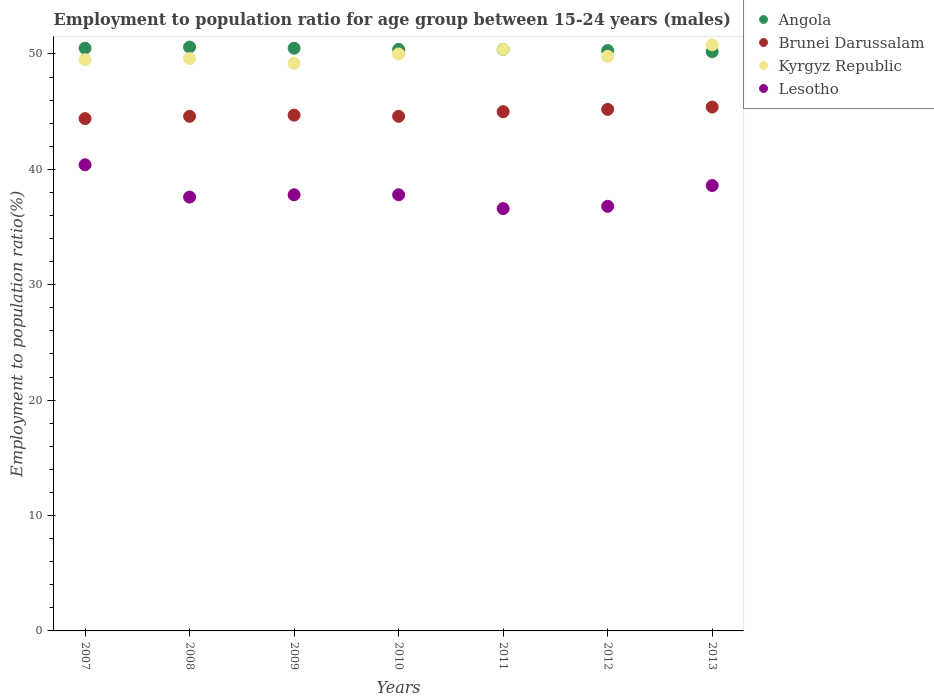Is the number of dotlines equal to the number of legend labels?
Provide a short and direct response. Yes. What is the employment to population ratio in Brunei Darussalam in 2009?
Your answer should be compact. 44.7. Across all years, what is the maximum employment to population ratio in Lesotho?
Your response must be concise. 40.4. Across all years, what is the minimum employment to population ratio in Angola?
Provide a short and direct response. 50.2. What is the total employment to population ratio in Angola in the graph?
Offer a very short reply. 352.9. What is the difference between the employment to population ratio in Lesotho in 2007 and that in 2010?
Your response must be concise. 2.6. What is the difference between the employment to population ratio in Angola in 2007 and the employment to population ratio in Brunei Darussalam in 2012?
Make the answer very short. 5.3. What is the average employment to population ratio in Brunei Darussalam per year?
Give a very brief answer. 44.84. In the year 2010, what is the difference between the employment to population ratio in Lesotho and employment to population ratio in Angola?
Give a very brief answer. -12.6. What is the ratio of the employment to population ratio in Kyrgyz Republic in 2008 to that in 2012?
Give a very brief answer. 1. Is the employment to population ratio in Angola in 2007 less than that in 2012?
Make the answer very short. No. What is the difference between the highest and the second highest employment to population ratio in Lesotho?
Keep it short and to the point. 1.8. What is the difference between the highest and the lowest employment to population ratio in Angola?
Provide a succinct answer. 0.4. In how many years, is the employment to population ratio in Angola greater than the average employment to population ratio in Angola taken over all years?
Your answer should be compact. 3. Is it the case that in every year, the sum of the employment to population ratio in Lesotho and employment to population ratio in Angola  is greater than the sum of employment to population ratio in Kyrgyz Republic and employment to population ratio in Brunei Darussalam?
Provide a short and direct response. No. Is it the case that in every year, the sum of the employment to population ratio in Kyrgyz Republic and employment to population ratio in Brunei Darussalam  is greater than the employment to population ratio in Lesotho?
Keep it short and to the point. Yes. Does the employment to population ratio in Angola monotonically increase over the years?
Your answer should be compact. No. Is the employment to population ratio in Brunei Darussalam strictly less than the employment to population ratio in Angola over the years?
Make the answer very short. Yes. How many dotlines are there?
Your response must be concise. 4. How many years are there in the graph?
Keep it short and to the point. 7. What is the difference between two consecutive major ticks on the Y-axis?
Your answer should be very brief. 10. Are the values on the major ticks of Y-axis written in scientific E-notation?
Your response must be concise. No. Where does the legend appear in the graph?
Your answer should be compact. Top right. What is the title of the graph?
Provide a short and direct response. Employment to population ratio for age group between 15-24 years (males). Does "Gabon" appear as one of the legend labels in the graph?
Offer a very short reply. No. What is the label or title of the X-axis?
Your answer should be very brief. Years. What is the label or title of the Y-axis?
Provide a short and direct response. Employment to population ratio(%). What is the Employment to population ratio(%) of Angola in 2007?
Offer a very short reply. 50.5. What is the Employment to population ratio(%) of Brunei Darussalam in 2007?
Offer a very short reply. 44.4. What is the Employment to population ratio(%) in Kyrgyz Republic in 2007?
Your response must be concise. 49.5. What is the Employment to population ratio(%) of Lesotho in 2007?
Offer a very short reply. 40.4. What is the Employment to population ratio(%) in Angola in 2008?
Your response must be concise. 50.6. What is the Employment to population ratio(%) in Brunei Darussalam in 2008?
Offer a terse response. 44.6. What is the Employment to population ratio(%) in Kyrgyz Republic in 2008?
Provide a succinct answer. 49.6. What is the Employment to population ratio(%) in Lesotho in 2008?
Your response must be concise. 37.6. What is the Employment to population ratio(%) of Angola in 2009?
Your answer should be very brief. 50.5. What is the Employment to population ratio(%) of Brunei Darussalam in 2009?
Ensure brevity in your answer.  44.7. What is the Employment to population ratio(%) of Kyrgyz Republic in 2009?
Your answer should be very brief. 49.2. What is the Employment to population ratio(%) in Lesotho in 2009?
Ensure brevity in your answer.  37.8. What is the Employment to population ratio(%) of Angola in 2010?
Offer a very short reply. 50.4. What is the Employment to population ratio(%) of Brunei Darussalam in 2010?
Keep it short and to the point. 44.6. What is the Employment to population ratio(%) in Lesotho in 2010?
Your answer should be very brief. 37.8. What is the Employment to population ratio(%) of Angola in 2011?
Provide a succinct answer. 50.4. What is the Employment to population ratio(%) in Kyrgyz Republic in 2011?
Your response must be concise. 50.4. What is the Employment to population ratio(%) in Lesotho in 2011?
Offer a terse response. 36.6. What is the Employment to population ratio(%) of Angola in 2012?
Provide a short and direct response. 50.3. What is the Employment to population ratio(%) in Brunei Darussalam in 2012?
Give a very brief answer. 45.2. What is the Employment to population ratio(%) of Kyrgyz Republic in 2012?
Offer a very short reply. 49.8. What is the Employment to population ratio(%) of Lesotho in 2012?
Offer a very short reply. 36.8. What is the Employment to population ratio(%) in Angola in 2013?
Make the answer very short. 50.2. What is the Employment to population ratio(%) of Brunei Darussalam in 2013?
Your answer should be compact. 45.4. What is the Employment to population ratio(%) in Kyrgyz Republic in 2013?
Provide a short and direct response. 50.8. What is the Employment to population ratio(%) in Lesotho in 2013?
Make the answer very short. 38.6. Across all years, what is the maximum Employment to population ratio(%) of Angola?
Provide a short and direct response. 50.6. Across all years, what is the maximum Employment to population ratio(%) of Brunei Darussalam?
Give a very brief answer. 45.4. Across all years, what is the maximum Employment to population ratio(%) in Kyrgyz Republic?
Ensure brevity in your answer.  50.8. Across all years, what is the maximum Employment to population ratio(%) of Lesotho?
Make the answer very short. 40.4. Across all years, what is the minimum Employment to population ratio(%) of Angola?
Ensure brevity in your answer.  50.2. Across all years, what is the minimum Employment to population ratio(%) of Brunei Darussalam?
Provide a short and direct response. 44.4. Across all years, what is the minimum Employment to population ratio(%) in Kyrgyz Republic?
Offer a very short reply. 49.2. Across all years, what is the minimum Employment to population ratio(%) of Lesotho?
Provide a short and direct response. 36.6. What is the total Employment to population ratio(%) of Angola in the graph?
Make the answer very short. 352.9. What is the total Employment to population ratio(%) in Brunei Darussalam in the graph?
Your answer should be very brief. 313.9. What is the total Employment to population ratio(%) in Kyrgyz Republic in the graph?
Keep it short and to the point. 349.3. What is the total Employment to population ratio(%) of Lesotho in the graph?
Offer a very short reply. 265.6. What is the difference between the Employment to population ratio(%) in Brunei Darussalam in 2007 and that in 2008?
Offer a very short reply. -0.2. What is the difference between the Employment to population ratio(%) of Kyrgyz Republic in 2007 and that in 2008?
Offer a very short reply. -0.1. What is the difference between the Employment to population ratio(%) of Brunei Darussalam in 2007 and that in 2009?
Offer a very short reply. -0.3. What is the difference between the Employment to population ratio(%) in Kyrgyz Republic in 2007 and that in 2009?
Make the answer very short. 0.3. What is the difference between the Employment to population ratio(%) in Lesotho in 2007 and that in 2009?
Provide a short and direct response. 2.6. What is the difference between the Employment to population ratio(%) in Angola in 2007 and that in 2010?
Keep it short and to the point. 0.1. What is the difference between the Employment to population ratio(%) in Lesotho in 2007 and that in 2010?
Make the answer very short. 2.6. What is the difference between the Employment to population ratio(%) of Angola in 2007 and that in 2011?
Your response must be concise. 0.1. What is the difference between the Employment to population ratio(%) of Brunei Darussalam in 2007 and that in 2011?
Your answer should be very brief. -0.6. What is the difference between the Employment to population ratio(%) in Kyrgyz Republic in 2007 and that in 2011?
Your response must be concise. -0.9. What is the difference between the Employment to population ratio(%) of Lesotho in 2007 and that in 2011?
Ensure brevity in your answer.  3.8. What is the difference between the Employment to population ratio(%) in Brunei Darussalam in 2007 and that in 2012?
Provide a short and direct response. -0.8. What is the difference between the Employment to population ratio(%) in Lesotho in 2007 and that in 2012?
Provide a succinct answer. 3.6. What is the difference between the Employment to population ratio(%) in Brunei Darussalam in 2007 and that in 2013?
Offer a very short reply. -1. What is the difference between the Employment to population ratio(%) of Kyrgyz Republic in 2007 and that in 2013?
Ensure brevity in your answer.  -1.3. What is the difference between the Employment to population ratio(%) of Angola in 2008 and that in 2009?
Your answer should be very brief. 0.1. What is the difference between the Employment to population ratio(%) in Brunei Darussalam in 2008 and that in 2009?
Give a very brief answer. -0.1. What is the difference between the Employment to population ratio(%) in Lesotho in 2008 and that in 2009?
Make the answer very short. -0.2. What is the difference between the Employment to population ratio(%) of Brunei Darussalam in 2008 and that in 2010?
Make the answer very short. 0. What is the difference between the Employment to population ratio(%) of Angola in 2008 and that in 2011?
Provide a short and direct response. 0.2. What is the difference between the Employment to population ratio(%) in Brunei Darussalam in 2008 and that in 2011?
Make the answer very short. -0.4. What is the difference between the Employment to population ratio(%) in Lesotho in 2008 and that in 2011?
Your answer should be very brief. 1. What is the difference between the Employment to population ratio(%) in Angola in 2008 and that in 2012?
Provide a succinct answer. 0.3. What is the difference between the Employment to population ratio(%) of Brunei Darussalam in 2008 and that in 2012?
Keep it short and to the point. -0.6. What is the difference between the Employment to population ratio(%) of Kyrgyz Republic in 2008 and that in 2012?
Provide a succinct answer. -0.2. What is the difference between the Employment to population ratio(%) in Lesotho in 2008 and that in 2012?
Your answer should be compact. 0.8. What is the difference between the Employment to population ratio(%) of Angola in 2008 and that in 2013?
Provide a succinct answer. 0.4. What is the difference between the Employment to population ratio(%) in Brunei Darussalam in 2008 and that in 2013?
Give a very brief answer. -0.8. What is the difference between the Employment to population ratio(%) of Kyrgyz Republic in 2008 and that in 2013?
Ensure brevity in your answer.  -1.2. What is the difference between the Employment to population ratio(%) in Lesotho in 2009 and that in 2011?
Make the answer very short. 1.2. What is the difference between the Employment to population ratio(%) in Angola in 2009 and that in 2012?
Offer a very short reply. 0.2. What is the difference between the Employment to population ratio(%) of Brunei Darussalam in 2009 and that in 2012?
Keep it short and to the point. -0.5. What is the difference between the Employment to population ratio(%) in Lesotho in 2009 and that in 2012?
Offer a very short reply. 1. What is the difference between the Employment to population ratio(%) in Angola in 2009 and that in 2013?
Keep it short and to the point. 0.3. What is the difference between the Employment to population ratio(%) in Kyrgyz Republic in 2009 and that in 2013?
Provide a short and direct response. -1.6. What is the difference between the Employment to population ratio(%) in Lesotho in 2009 and that in 2013?
Provide a succinct answer. -0.8. What is the difference between the Employment to population ratio(%) in Angola in 2010 and that in 2011?
Your response must be concise. 0. What is the difference between the Employment to population ratio(%) of Angola in 2010 and that in 2012?
Offer a terse response. 0.1. What is the difference between the Employment to population ratio(%) in Kyrgyz Republic in 2010 and that in 2012?
Provide a succinct answer. 0.2. What is the difference between the Employment to population ratio(%) of Angola in 2010 and that in 2013?
Provide a short and direct response. 0.2. What is the difference between the Employment to population ratio(%) of Brunei Darussalam in 2010 and that in 2013?
Provide a short and direct response. -0.8. What is the difference between the Employment to population ratio(%) of Kyrgyz Republic in 2010 and that in 2013?
Ensure brevity in your answer.  -0.8. What is the difference between the Employment to population ratio(%) of Angola in 2011 and that in 2012?
Make the answer very short. 0.1. What is the difference between the Employment to population ratio(%) in Kyrgyz Republic in 2011 and that in 2012?
Offer a terse response. 0.6. What is the difference between the Employment to population ratio(%) of Angola in 2011 and that in 2013?
Give a very brief answer. 0.2. What is the difference between the Employment to population ratio(%) in Kyrgyz Republic in 2011 and that in 2013?
Provide a succinct answer. -0.4. What is the difference between the Employment to population ratio(%) in Lesotho in 2012 and that in 2013?
Offer a terse response. -1.8. What is the difference between the Employment to population ratio(%) in Angola in 2007 and the Employment to population ratio(%) in Brunei Darussalam in 2008?
Offer a very short reply. 5.9. What is the difference between the Employment to population ratio(%) of Angola in 2007 and the Employment to population ratio(%) of Lesotho in 2008?
Provide a short and direct response. 12.9. What is the difference between the Employment to population ratio(%) in Angola in 2007 and the Employment to population ratio(%) in Brunei Darussalam in 2010?
Keep it short and to the point. 5.9. What is the difference between the Employment to population ratio(%) in Angola in 2007 and the Employment to population ratio(%) in Kyrgyz Republic in 2010?
Make the answer very short. 0.5. What is the difference between the Employment to population ratio(%) of Angola in 2007 and the Employment to population ratio(%) of Lesotho in 2010?
Offer a very short reply. 12.7. What is the difference between the Employment to population ratio(%) of Angola in 2007 and the Employment to population ratio(%) of Brunei Darussalam in 2011?
Provide a succinct answer. 5.5. What is the difference between the Employment to population ratio(%) of Angola in 2007 and the Employment to population ratio(%) of Kyrgyz Republic in 2011?
Make the answer very short. 0.1. What is the difference between the Employment to population ratio(%) of Brunei Darussalam in 2007 and the Employment to population ratio(%) of Lesotho in 2011?
Your answer should be very brief. 7.8. What is the difference between the Employment to population ratio(%) of Kyrgyz Republic in 2007 and the Employment to population ratio(%) of Lesotho in 2011?
Give a very brief answer. 12.9. What is the difference between the Employment to population ratio(%) of Angola in 2007 and the Employment to population ratio(%) of Brunei Darussalam in 2012?
Offer a terse response. 5.3. What is the difference between the Employment to population ratio(%) in Kyrgyz Republic in 2007 and the Employment to population ratio(%) in Lesotho in 2012?
Ensure brevity in your answer.  12.7. What is the difference between the Employment to population ratio(%) in Angola in 2007 and the Employment to population ratio(%) in Brunei Darussalam in 2013?
Your answer should be compact. 5.1. What is the difference between the Employment to population ratio(%) in Angola in 2007 and the Employment to population ratio(%) in Lesotho in 2013?
Your response must be concise. 11.9. What is the difference between the Employment to population ratio(%) of Kyrgyz Republic in 2007 and the Employment to population ratio(%) of Lesotho in 2013?
Your response must be concise. 10.9. What is the difference between the Employment to population ratio(%) of Angola in 2008 and the Employment to population ratio(%) of Brunei Darussalam in 2009?
Offer a terse response. 5.9. What is the difference between the Employment to population ratio(%) in Angola in 2008 and the Employment to population ratio(%) in Kyrgyz Republic in 2009?
Keep it short and to the point. 1.4. What is the difference between the Employment to population ratio(%) of Brunei Darussalam in 2008 and the Employment to population ratio(%) of Kyrgyz Republic in 2009?
Provide a succinct answer. -4.6. What is the difference between the Employment to population ratio(%) in Angola in 2008 and the Employment to population ratio(%) in Kyrgyz Republic in 2011?
Your answer should be very brief. 0.2. What is the difference between the Employment to population ratio(%) of Angola in 2008 and the Employment to population ratio(%) of Lesotho in 2011?
Your response must be concise. 14. What is the difference between the Employment to population ratio(%) of Brunei Darussalam in 2008 and the Employment to population ratio(%) of Kyrgyz Republic in 2011?
Your answer should be compact. -5.8. What is the difference between the Employment to population ratio(%) in Brunei Darussalam in 2008 and the Employment to population ratio(%) in Lesotho in 2011?
Keep it short and to the point. 8. What is the difference between the Employment to population ratio(%) of Kyrgyz Republic in 2008 and the Employment to population ratio(%) of Lesotho in 2011?
Give a very brief answer. 13. What is the difference between the Employment to population ratio(%) of Angola in 2008 and the Employment to population ratio(%) of Brunei Darussalam in 2012?
Give a very brief answer. 5.4. What is the difference between the Employment to population ratio(%) in Angola in 2008 and the Employment to population ratio(%) in Kyrgyz Republic in 2012?
Your response must be concise. 0.8. What is the difference between the Employment to population ratio(%) of Angola in 2008 and the Employment to population ratio(%) of Lesotho in 2012?
Provide a succinct answer. 13.8. What is the difference between the Employment to population ratio(%) of Brunei Darussalam in 2008 and the Employment to population ratio(%) of Lesotho in 2012?
Ensure brevity in your answer.  7.8. What is the difference between the Employment to population ratio(%) of Angola in 2008 and the Employment to population ratio(%) of Brunei Darussalam in 2013?
Keep it short and to the point. 5.2. What is the difference between the Employment to population ratio(%) of Angola in 2008 and the Employment to population ratio(%) of Kyrgyz Republic in 2013?
Your answer should be compact. -0.2. What is the difference between the Employment to population ratio(%) of Angola in 2008 and the Employment to population ratio(%) of Lesotho in 2013?
Keep it short and to the point. 12. What is the difference between the Employment to population ratio(%) in Brunei Darussalam in 2008 and the Employment to population ratio(%) in Kyrgyz Republic in 2013?
Ensure brevity in your answer.  -6.2. What is the difference between the Employment to population ratio(%) in Kyrgyz Republic in 2008 and the Employment to population ratio(%) in Lesotho in 2013?
Keep it short and to the point. 11. What is the difference between the Employment to population ratio(%) in Angola in 2009 and the Employment to population ratio(%) in Brunei Darussalam in 2010?
Your response must be concise. 5.9. What is the difference between the Employment to population ratio(%) in Angola in 2009 and the Employment to population ratio(%) in Lesotho in 2010?
Your response must be concise. 12.7. What is the difference between the Employment to population ratio(%) in Brunei Darussalam in 2009 and the Employment to population ratio(%) in Kyrgyz Republic in 2010?
Keep it short and to the point. -5.3. What is the difference between the Employment to population ratio(%) of Brunei Darussalam in 2009 and the Employment to population ratio(%) of Lesotho in 2010?
Make the answer very short. 6.9. What is the difference between the Employment to population ratio(%) of Kyrgyz Republic in 2009 and the Employment to population ratio(%) of Lesotho in 2010?
Ensure brevity in your answer.  11.4. What is the difference between the Employment to population ratio(%) in Angola in 2009 and the Employment to population ratio(%) in Brunei Darussalam in 2011?
Give a very brief answer. 5.5. What is the difference between the Employment to population ratio(%) of Brunei Darussalam in 2009 and the Employment to population ratio(%) of Kyrgyz Republic in 2011?
Make the answer very short. -5.7. What is the difference between the Employment to population ratio(%) of Brunei Darussalam in 2009 and the Employment to population ratio(%) of Lesotho in 2011?
Your answer should be very brief. 8.1. What is the difference between the Employment to population ratio(%) in Angola in 2009 and the Employment to population ratio(%) in Lesotho in 2012?
Give a very brief answer. 13.7. What is the difference between the Employment to population ratio(%) of Brunei Darussalam in 2009 and the Employment to population ratio(%) of Kyrgyz Republic in 2012?
Offer a very short reply. -5.1. What is the difference between the Employment to population ratio(%) of Angola in 2009 and the Employment to population ratio(%) of Kyrgyz Republic in 2013?
Your answer should be very brief. -0.3. What is the difference between the Employment to population ratio(%) in Angola in 2009 and the Employment to population ratio(%) in Lesotho in 2013?
Provide a short and direct response. 11.9. What is the difference between the Employment to population ratio(%) of Brunei Darussalam in 2009 and the Employment to population ratio(%) of Kyrgyz Republic in 2013?
Your response must be concise. -6.1. What is the difference between the Employment to population ratio(%) in Brunei Darussalam in 2009 and the Employment to population ratio(%) in Lesotho in 2013?
Offer a very short reply. 6.1. What is the difference between the Employment to population ratio(%) in Kyrgyz Republic in 2009 and the Employment to population ratio(%) in Lesotho in 2013?
Ensure brevity in your answer.  10.6. What is the difference between the Employment to population ratio(%) in Angola in 2010 and the Employment to population ratio(%) in Lesotho in 2012?
Your response must be concise. 13.6. What is the difference between the Employment to population ratio(%) in Brunei Darussalam in 2010 and the Employment to population ratio(%) in Lesotho in 2012?
Your answer should be compact. 7.8. What is the difference between the Employment to population ratio(%) of Kyrgyz Republic in 2010 and the Employment to population ratio(%) of Lesotho in 2012?
Your answer should be very brief. 13.2. What is the difference between the Employment to population ratio(%) of Angola in 2010 and the Employment to population ratio(%) of Brunei Darussalam in 2013?
Your answer should be very brief. 5. What is the difference between the Employment to population ratio(%) of Angola in 2010 and the Employment to population ratio(%) of Lesotho in 2013?
Make the answer very short. 11.8. What is the difference between the Employment to population ratio(%) of Brunei Darussalam in 2010 and the Employment to population ratio(%) of Lesotho in 2013?
Provide a short and direct response. 6. What is the difference between the Employment to population ratio(%) in Kyrgyz Republic in 2010 and the Employment to population ratio(%) in Lesotho in 2013?
Provide a succinct answer. 11.4. What is the difference between the Employment to population ratio(%) of Angola in 2011 and the Employment to population ratio(%) of Brunei Darussalam in 2012?
Keep it short and to the point. 5.2. What is the difference between the Employment to population ratio(%) of Angola in 2011 and the Employment to population ratio(%) of Lesotho in 2012?
Give a very brief answer. 13.6. What is the difference between the Employment to population ratio(%) in Brunei Darussalam in 2011 and the Employment to population ratio(%) in Kyrgyz Republic in 2012?
Provide a succinct answer. -4.8. What is the difference between the Employment to population ratio(%) of Brunei Darussalam in 2011 and the Employment to population ratio(%) of Lesotho in 2012?
Ensure brevity in your answer.  8.2. What is the difference between the Employment to population ratio(%) of Angola in 2011 and the Employment to population ratio(%) of Lesotho in 2013?
Your response must be concise. 11.8. What is the difference between the Employment to population ratio(%) of Brunei Darussalam in 2011 and the Employment to population ratio(%) of Lesotho in 2013?
Offer a terse response. 6.4. What is the difference between the Employment to population ratio(%) of Angola in 2012 and the Employment to population ratio(%) of Kyrgyz Republic in 2013?
Provide a succinct answer. -0.5. What is the difference between the Employment to population ratio(%) of Kyrgyz Republic in 2012 and the Employment to population ratio(%) of Lesotho in 2013?
Provide a succinct answer. 11.2. What is the average Employment to population ratio(%) in Angola per year?
Offer a terse response. 50.41. What is the average Employment to population ratio(%) of Brunei Darussalam per year?
Make the answer very short. 44.84. What is the average Employment to population ratio(%) of Kyrgyz Republic per year?
Offer a terse response. 49.9. What is the average Employment to population ratio(%) of Lesotho per year?
Offer a very short reply. 37.94. In the year 2007, what is the difference between the Employment to population ratio(%) of Angola and Employment to population ratio(%) of Kyrgyz Republic?
Offer a terse response. 1. In the year 2007, what is the difference between the Employment to population ratio(%) of Angola and Employment to population ratio(%) of Lesotho?
Give a very brief answer. 10.1. In the year 2007, what is the difference between the Employment to population ratio(%) in Brunei Darussalam and Employment to population ratio(%) in Kyrgyz Republic?
Give a very brief answer. -5.1. In the year 2007, what is the difference between the Employment to population ratio(%) in Brunei Darussalam and Employment to population ratio(%) in Lesotho?
Ensure brevity in your answer.  4. In the year 2008, what is the difference between the Employment to population ratio(%) in Angola and Employment to population ratio(%) in Brunei Darussalam?
Your answer should be compact. 6. In the year 2008, what is the difference between the Employment to population ratio(%) in Kyrgyz Republic and Employment to population ratio(%) in Lesotho?
Give a very brief answer. 12. In the year 2009, what is the difference between the Employment to population ratio(%) in Angola and Employment to population ratio(%) in Brunei Darussalam?
Your response must be concise. 5.8. In the year 2009, what is the difference between the Employment to population ratio(%) of Angola and Employment to population ratio(%) of Kyrgyz Republic?
Your answer should be compact. 1.3. In the year 2009, what is the difference between the Employment to population ratio(%) in Angola and Employment to population ratio(%) in Lesotho?
Ensure brevity in your answer.  12.7. In the year 2009, what is the difference between the Employment to population ratio(%) in Brunei Darussalam and Employment to population ratio(%) in Kyrgyz Republic?
Provide a short and direct response. -4.5. In the year 2009, what is the difference between the Employment to population ratio(%) in Brunei Darussalam and Employment to population ratio(%) in Lesotho?
Offer a very short reply. 6.9. In the year 2009, what is the difference between the Employment to population ratio(%) of Kyrgyz Republic and Employment to population ratio(%) of Lesotho?
Ensure brevity in your answer.  11.4. In the year 2010, what is the difference between the Employment to population ratio(%) in Angola and Employment to population ratio(%) in Lesotho?
Your answer should be very brief. 12.6. In the year 2011, what is the difference between the Employment to population ratio(%) of Angola and Employment to population ratio(%) of Lesotho?
Provide a short and direct response. 13.8. In the year 2011, what is the difference between the Employment to population ratio(%) in Brunei Darussalam and Employment to population ratio(%) in Kyrgyz Republic?
Offer a terse response. -5.4. In the year 2011, what is the difference between the Employment to population ratio(%) of Brunei Darussalam and Employment to population ratio(%) of Lesotho?
Your answer should be very brief. 8.4. In the year 2011, what is the difference between the Employment to population ratio(%) in Kyrgyz Republic and Employment to population ratio(%) in Lesotho?
Provide a succinct answer. 13.8. In the year 2012, what is the difference between the Employment to population ratio(%) of Angola and Employment to population ratio(%) of Brunei Darussalam?
Your answer should be compact. 5.1. In the year 2012, what is the difference between the Employment to population ratio(%) in Brunei Darussalam and Employment to population ratio(%) in Lesotho?
Provide a short and direct response. 8.4. In the year 2012, what is the difference between the Employment to population ratio(%) of Kyrgyz Republic and Employment to population ratio(%) of Lesotho?
Provide a short and direct response. 13. In the year 2013, what is the difference between the Employment to population ratio(%) of Brunei Darussalam and Employment to population ratio(%) of Lesotho?
Your answer should be very brief. 6.8. In the year 2013, what is the difference between the Employment to population ratio(%) in Kyrgyz Republic and Employment to population ratio(%) in Lesotho?
Your answer should be very brief. 12.2. What is the ratio of the Employment to population ratio(%) of Angola in 2007 to that in 2008?
Your response must be concise. 1. What is the ratio of the Employment to population ratio(%) in Brunei Darussalam in 2007 to that in 2008?
Your answer should be compact. 1. What is the ratio of the Employment to population ratio(%) in Kyrgyz Republic in 2007 to that in 2008?
Give a very brief answer. 1. What is the ratio of the Employment to population ratio(%) of Lesotho in 2007 to that in 2008?
Your answer should be compact. 1.07. What is the ratio of the Employment to population ratio(%) of Brunei Darussalam in 2007 to that in 2009?
Your response must be concise. 0.99. What is the ratio of the Employment to population ratio(%) in Kyrgyz Republic in 2007 to that in 2009?
Ensure brevity in your answer.  1.01. What is the ratio of the Employment to population ratio(%) in Lesotho in 2007 to that in 2009?
Offer a terse response. 1.07. What is the ratio of the Employment to population ratio(%) of Angola in 2007 to that in 2010?
Ensure brevity in your answer.  1. What is the ratio of the Employment to population ratio(%) of Kyrgyz Republic in 2007 to that in 2010?
Your answer should be very brief. 0.99. What is the ratio of the Employment to population ratio(%) in Lesotho in 2007 to that in 2010?
Give a very brief answer. 1.07. What is the ratio of the Employment to population ratio(%) of Brunei Darussalam in 2007 to that in 2011?
Offer a very short reply. 0.99. What is the ratio of the Employment to population ratio(%) of Kyrgyz Republic in 2007 to that in 2011?
Your answer should be compact. 0.98. What is the ratio of the Employment to population ratio(%) of Lesotho in 2007 to that in 2011?
Offer a very short reply. 1.1. What is the ratio of the Employment to population ratio(%) of Brunei Darussalam in 2007 to that in 2012?
Provide a succinct answer. 0.98. What is the ratio of the Employment to population ratio(%) in Kyrgyz Republic in 2007 to that in 2012?
Ensure brevity in your answer.  0.99. What is the ratio of the Employment to population ratio(%) of Lesotho in 2007 to that in 2012?
Keep it short and to the point. 1.1. What is the ratio of the Employment to population ratio(%) in Kyrgyz Republic in 2007 to that in 2013?
Make the answer very short. 0.97. What is the ratio of the Employment to population ratio(%) in Lesotho in 2007 to that in 2013?
Give a very brief answer. 1.05. What is the ratio of the Employment to population ratio(%) in Angola in 2008 to that in 2009?
Keep it short and to the point. 1. What is the ratio of the Employment to population ratio(%) in Brunei Darussalam in 2008 to that in 2009?
Offer a terse response. 1. What is the ratio of the Employment to population ratio(%) of Kyrgyz Republic in 2008 to that in 2009?
Your answer should be compact. 1.01. What is the ratio of the Employment to population ratio(%) in Angola in 2008 to that in 2010?
Your response must be concise. 1. What is the ratio of the Employment to population ratio(%) in Kyrgyz Republic in 2008 to that in 2010?
Make the answer very short. 0.99. What is the ratio of the Employment to population ratio(%) in Lesotho in 2008 to that in 2010?
Offer a very short reply. 0.99. What is the ratio of the Employment to population ratio(%) of Brunei Darussalam in 2008 to that in 2011?
Ensure brevity in your answer.  0.99. What is the ratio of the Employment to population ratio(%) of Kyrgyz Republic in 2008 to that in 2011?
Your response must be concise. 0.98. What is the ratio of the Employment to population ratio(%) of Lesotho in 2008 to that in 2011?
Provide a succinct answer. 1.03. What is the ratio of the Employment to population ratio(%) of Brunei Darussalam in 2008 to that in 2012?
Your answer should be very brief. 0.99. What is the ratio of the Employment to population ratio(%) in Lesotho in 2008 to that in 2012?
Ensure brevity in your answer.  1.02. What is the ratio of the Employment to population ratio(%) in Angola in 2008 to that in 2013?
Your answer should be very brief. 1.01. What is the ratio of the Employment to population ratio(%) in Brunei Darussalam in 2008 to that in 2013?
Ensure brevity in your answer.  0.98. What is the ratio of the Employment to population ratio(%) in Kyrgyz Republic in 2008 to that in 2013?
Provide a succinct answer. 0.98. What is the ratio of the Employment to population ratio(%) in Lesotho in 2008 to that in 2013?
Give a very brief answer. 0.97. What is the ratio of the Employment to population ratio(%) of Brunei Darussalam in 2009 to that in 2010?
Make the answer very short. 1. What is the ratio of the Employment to population ratio(%) in Angola in 2009 to that in 2011?
Keep it short and to the point. 1. What is the ratio of the Employment to population ratio(%) of Kyrgyz Republic in 2009 to that in 2011?
Your answer should be compact. 0.98. What is the ratio of the Employment to population ratio(%) in Lesotho in 2009 to that in 2011?
Keep it short and to the point. 1.03. What is the ratio of the Employment to population ratio(%) of Angola in 2009 to that in 2012?
Provide a short and direct response. 1. What is the ratio of the Employment to population ratio(%) in Brunei Darussalam in 2009 to that in 2012?
Provide a short and direct response. 0.99. What is the ratio of the Employment to population ratio(%) in Lesotho in 2009 to that in 2012?
Your answer should be very brief. 1.03. What is the ratio of the Employment to population ratio(%) in Angola in 2009 to that in 2013?
Keep it short and to the point. 1.01. What is the ratio of the Employment to population ratio(%) of Brunei Darussalam in 2009 to that in 2013?
Offer a terse response. 0.98. What is the ratio of the Employment to population ratio(%) of Kyrgyz Republic in 2009 to that in 2013?
Offer a terse response. 0.97. What is the ratio of the Employment to population ratio(%) of Lesotho in 2009 to that in 2013?
Your answer should be very brief. 0.98. What is the ratio of the Employment to population ratio(%) in Kyrgyz Republic in 2010 to that in 2011?
Your response must be concise. 0.99. What is the ratio of the Employment to population ratio(%) of Lesotho in 2010 to that in 2011?
Provide a succinct answer. 1.03. What is the ratio of the Employment to population ratio(%) in Brunei Darussalam in 2010 to that in 2012?
Make the answer very short. 0.99. What is the ratio of the Employment to population ratio(%) of Lesotho in 2010 to that in 2012?
Your answer should be very brief. 1.03. What is the ratio of the Employment to population ratio(%) of Brunei Darussalam in 2010 to that in 2013?
Provide a short and direct response. 0.98. What is the ratio of the Employment to population ratio(%) in Kyrgyz Republic in 2010 to that in 2013?
Your answer should be very brief. 0.98. What is the ratio of the Employment to population ratio(%) in Lesotho in 2010 to that in 2013?
Provide a succinct answer. 0.98. What is the ratio of the Employment to population ratio(%) of Kyrgyz Republic in 2011 to that in 2012?
Provide a short and direct response. 1.01. What is the ratio of the Employment to population ratio(%) in Angola in 2011 to that in 2013?
Give a very brief answer. 1. What is the ratio of the Employment to population ratio(%) in Brunei Darussalam in 2011 to that in 2013?
Make the answer very short. 0.99. What is the ratio of the Employment to population ratio(%) in Lesotho in 2011 to that in 2013?
Ensure brevity in your answer.  0.95. What is the ratio of the Employment to population ratio(%) in Kyrgyz Republic in 2012 to that in 2013?
Provide a short and direct response. 0.98. What is the ratio of the Employment to population ratio(%) of Lesotho in 2012 to that in 2013?
Your response must be concise. 0.95. What is the difference between the highest and the lowest Employment to population ratio(%) in Angola?
Offer a very short reply. 0.4. What is the difference between the highest and the lowest Employment to population ratio(%) of Brunei Darussalam?
Make the answer very short. 1. 